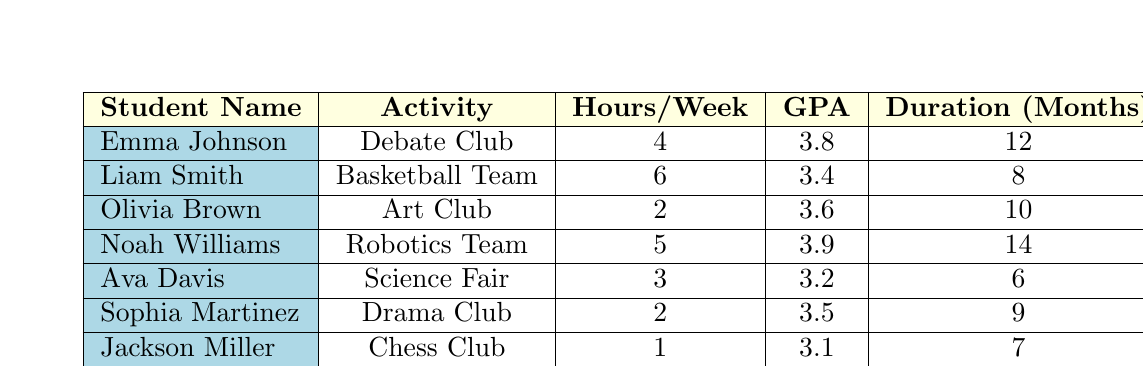What is the GPA of Noah Williams? Referring directly to the table, Noah Williams has a listed GPA of 3.9.
Answer: 3.9 Which student participates in the most hours of extracurricular activities per week? Looking across the "Hours/Week" column, Liam Smith participates in 6 hours per week, which is the highest among all entries.
Answer: Liam Smith What is the average GPA of students who participate in activities for more than 10 months? The students with participation durations of more than 10 months are Emma Johnson (GPA 3.8) and Noah Williams (GPA 3.9). The average GPA is (3.8 + 3.9) / 2 = 3.85.
Answer: 3.85 Is it true that students who are involved in more extracurricular hours have higher GPAs? Looking at the data, the GPAs of students participating in more than 4 hours per week are 3.8 (Emma), 3.4 (Liam), 3.9 (Noah), and 3.7 (Mason). The GPAs vary, so the claim is not definitively supported.
Answer: No How many students have a GPA below 3.5? The table shows Ava Davis (3.2), Jackson Miller (3.1), and Sophia Martinez (3.5) have GPAs below 3.5. Therefore, there are 2 students with GPAs below 3.5: Ava Davis and Jackson Miller.
Answer: 2 What is the total number of extracurricular hours participated in by all students? To find the total, we sum up all "Hours/Week": 4 + 6 + 2 + 5 + 3 + 2 + 1 + 4 = 27 hours in total across all students.
Answer: 27 Who has the highest GPA and for how long have they participated in their activity? Noah Williams has the highest GPA of 3.9, and he has participated in the Robotics Team for 14 months.
Answer: Noah Williams, 14 months What is the difference between the highest and lowest GPAs in the table? The highest GPA is 3.9 (Noah Williams) and the lowest GPA is 3.1 (Jackson Miller). The difference is calculated as 3.9 - 3.1 = 0.8.
Answer: 0.8 